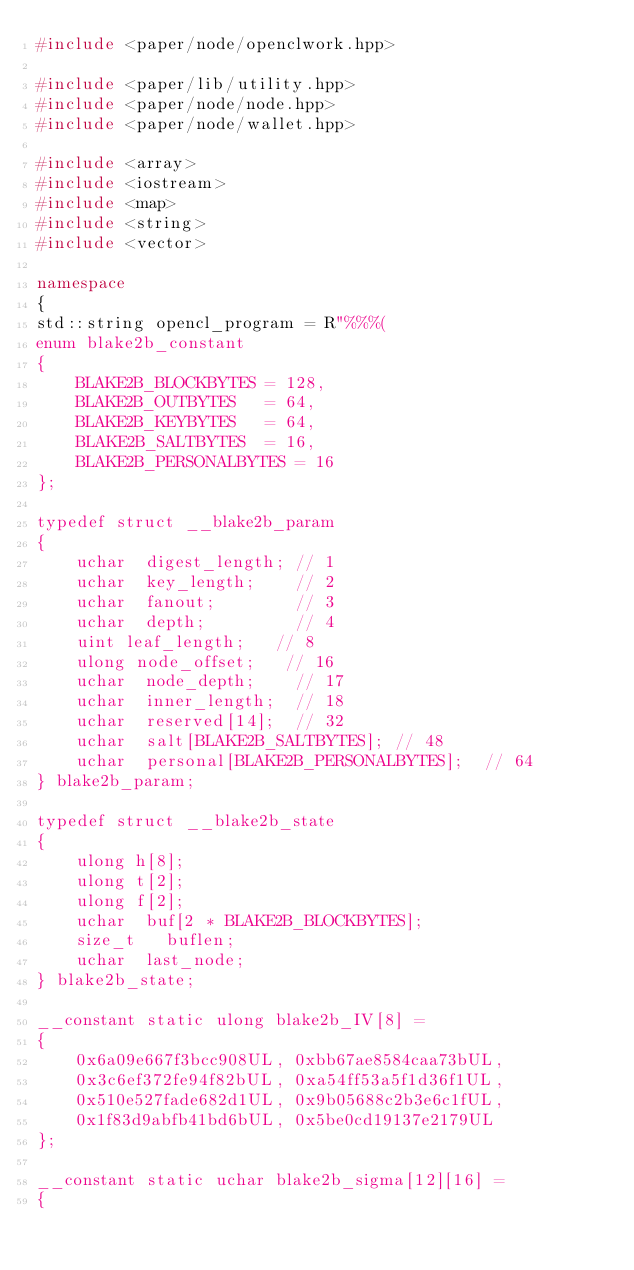<code> <loc_0><loc_0><loc_500><loc_500><_C++_>#include <paper/node/openclwork.hpp>

#include <paper/lib/utility.hpp>
#include <paper/node/node.hpp>
#include <paper/node/wallet.hpp>

#include <array>
#include <iostream>
#include <map>
#include <string>
#include <vector>

namespace
{
std::string opencl_program = R"%%%(
enum blake2b_constant
{
	BLAKE2B_BLOCKBYTES = 128,
	BLAKE2B_OUTBYTES   = 64,
	BLAKE2B_KEYBYTES   = 64,
	BLAKE2B_SALTBYTES  = 16,
	BLAKE2B_PERSONALBYTES = 16
};

typedef struct __blake2b_param
{
	uchar  digest_length; // 1
	uchar  key_length;    // 2
	uchar  fanout;        // 3
	uchar  depth;         // 4
	uint leaf_length;   // 8
	ulong node_offset;   // 16
	uchar  node_depth;    // 17
	uchar  inner_length;  // 18
	uchar  reserved[14];  // 32
	uchar  salt[BLAKE2B_SALTBYTES]; // 48
	uchar  personal[BLAKE2B_PERSONALBYTES];  // 64
} blake2b_param;

typedef struct __blake2b_state
{
	ulong h[8];
	ulong t[2];
	ulong f[2];
	uchar  buf[2 * BLAKE2B_BLOCKBYTES];
	size_t   buflen;
	uchar  last_node;
} blake2b_state;

__constant static ulong blake2b_IV[8] =
{
	0x6a09e667f3bcc908UL, 0xbb67ae8584caa73bUL,
	0x3c6ef372fe94f82bUL, 0xa54ff53a5f1d36f1UL,
	0x510e527fade682d1UL, 0x9b05688c2b3e6c1fUL,
	0x1f83d9abfb41bd6bUL, 0x5be0cd19137e2179UL
};

__constant static uchar blake2b_sigma[12][16] =
{</code> 